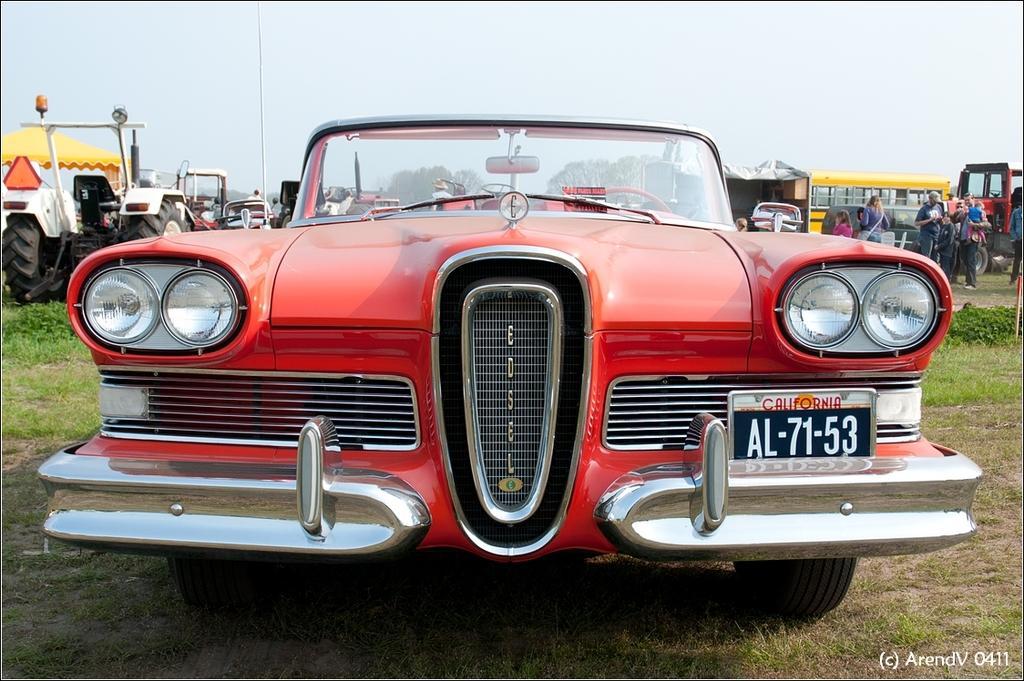Could you give a brief overview of what you see in this image? This image consists of a car in red color. At the bottom, there is green grass. On the left, we can see a tractor and a tent in yellow color. On the right, we can see a bus in yellow color. In the background, we can see the trees. At the top, there is sky. 